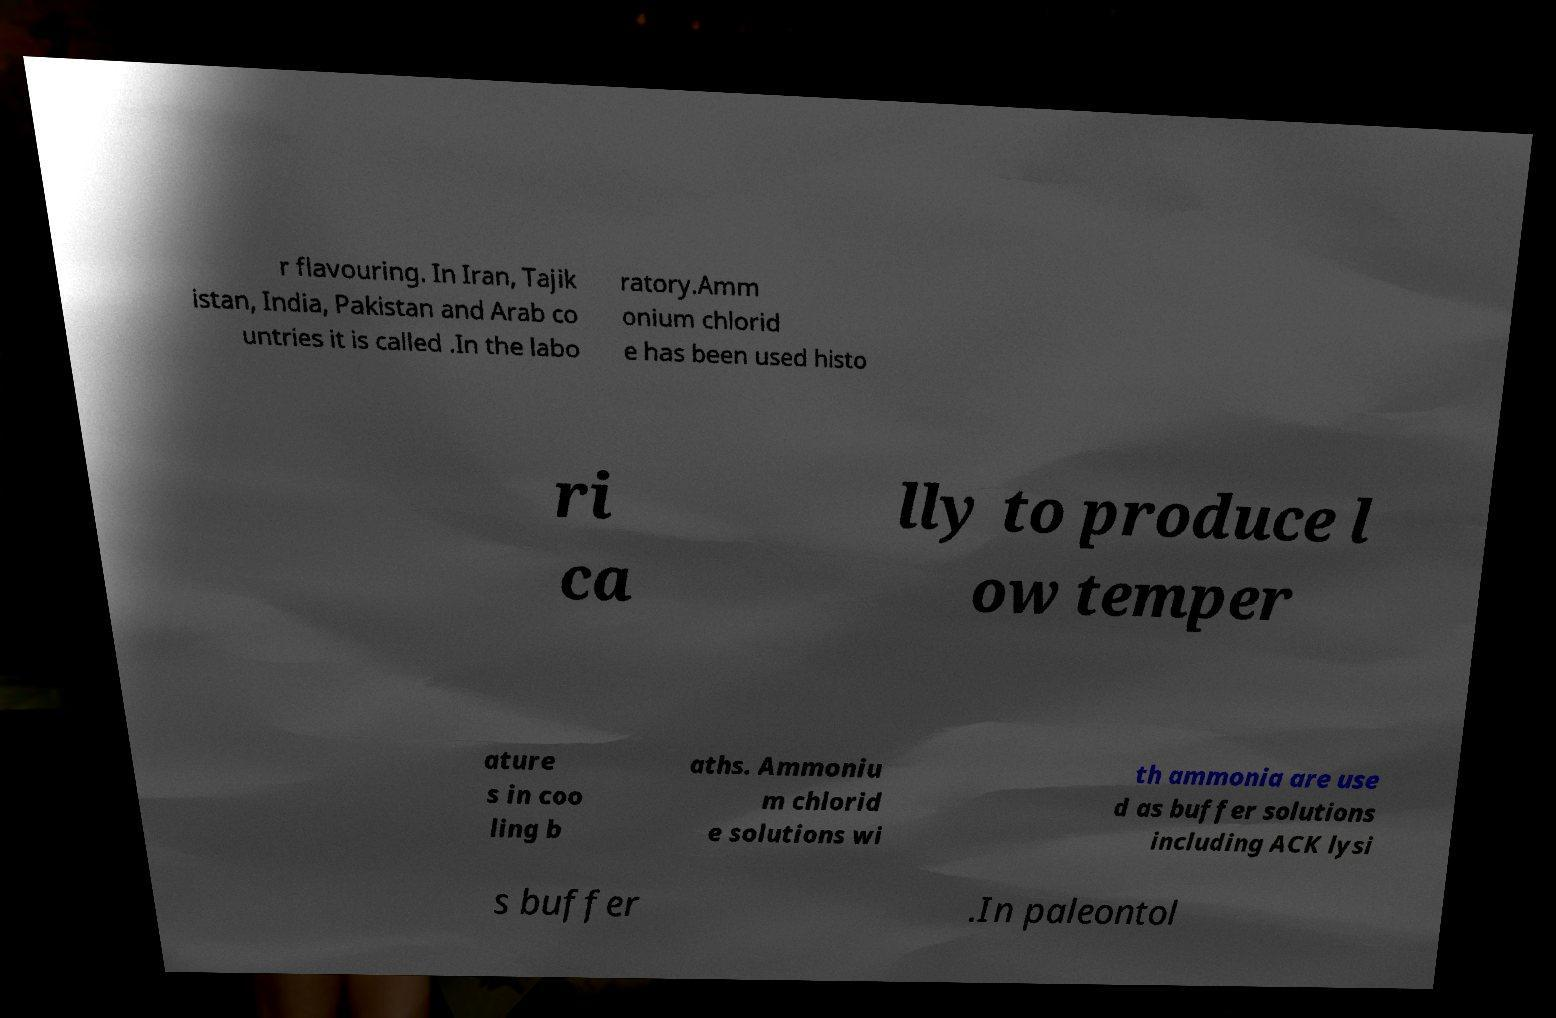Could you assist in decoding the text presented in this image and type it out clearly? r flavouring. In Iran, Tajik istan, India, Pakistan and Arab co untries it is called .In the labo ratory.Amm onium chlorid e has been used histo ri ca lly to produce l ow temper ature s in coo ling b aths. Ammoniu m chlorid e solutions wi th ammonia are use d as buffer solutions including ACK lysi s buffer .In paleontol 